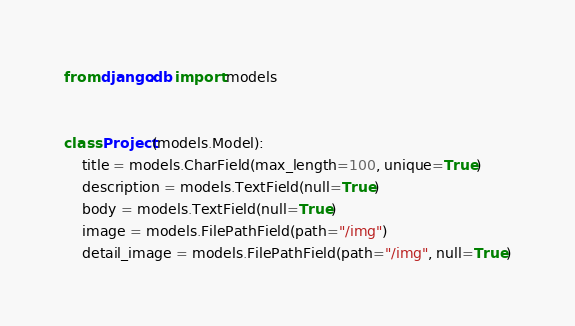<code> <loc_0><loc_0><loc_500><loc_500><_Python_>from django.db import models


class Project(models.Model):
    title = models.CharField(max_length=100, unique=True)
    description = models.TextField(null=True)
    body = models.TextField(null=True)
    image = models.FilePathField(path="/img")
    detail_image = models.FilePathField(path="/img", null=True)
</code> 